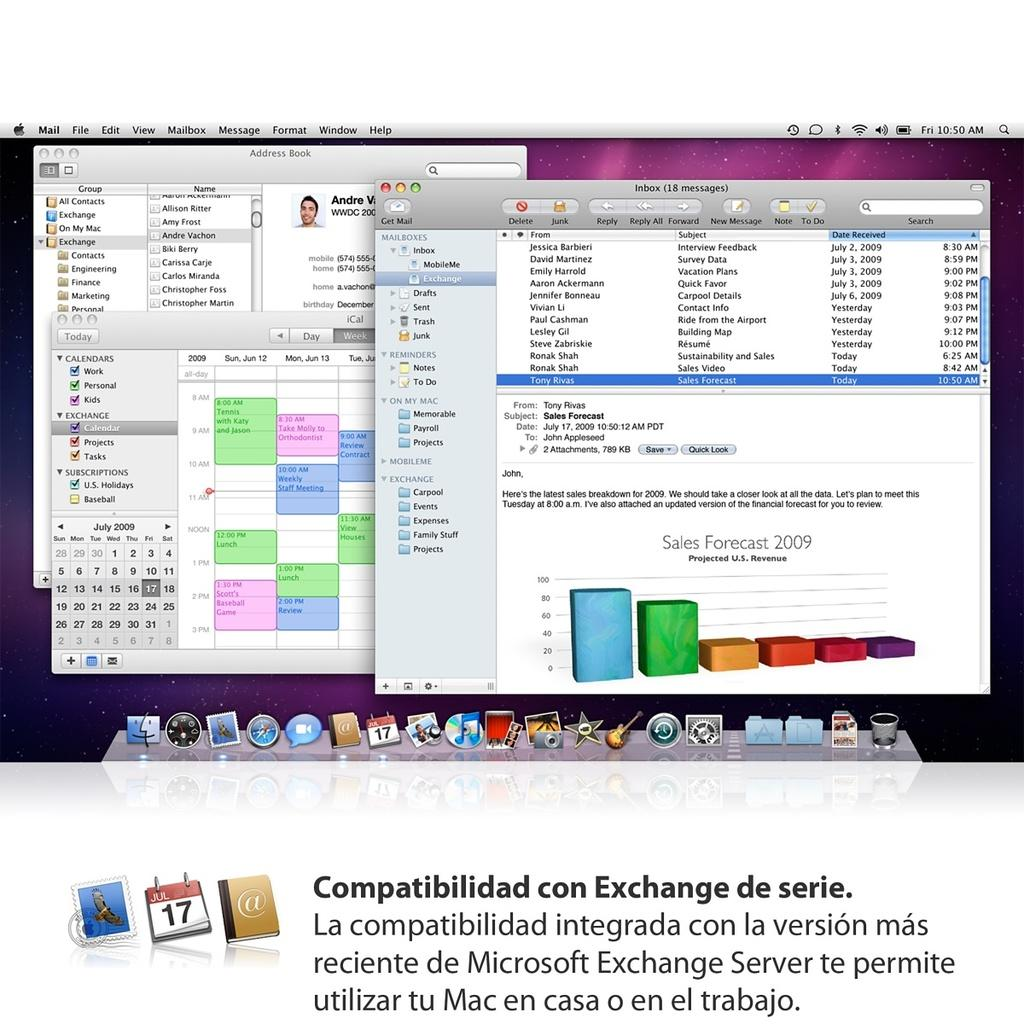Provide a one-sentence caption for the provided image. A few windows up on a screen with "Compatibilidad con Exchange de series" written below it. 